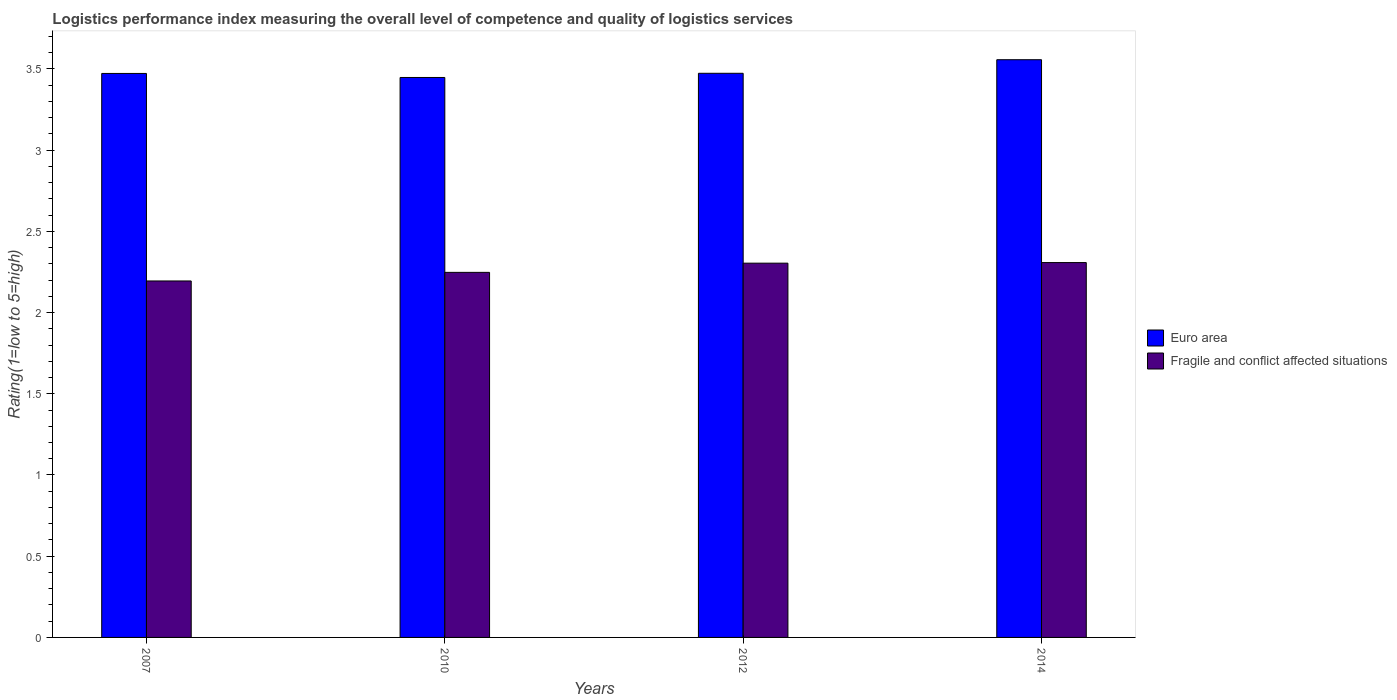How many different coloured bars are there?
Give a very brief answer. 2. How many bars are there on the 2nd tick from the left?
Your answer should be very brief. 2. What is the Logistic performance index in Euro area in 2012?
Ensure brevity in your answer.  3.47. Across all years, what is the maximum Logistic performance index in Fragile and conflict affected situations?
Provide a succinct answer. 2.31. Across all years, what is the minimum Logistic performance index in Fragile and conflict affected situations?
Give a very brief answer. 2.19. In which year was the Logistic performance index in Fragile and conflict affected situations minimum?
Your response must be concise. 2007. What is the total Logistic performance index in Euro area in the graph?
Provide a short and direct response. 13.95. What is the difference between the Logistic performance index in Fragile and conflict affected situations in 2007 and that in 2012?
Offer a terse response. -0.11. What is the difference between the Logistic performance index in Fragile and conflict affected situations in 2010 and the Logistic performance index in Euro area in 2014?
Your response must be concise. -1.31. What is the average Logistic performance index in Euro area per year?
Give a very brief answer. 3.49. In the year 2012, what is the difference between the Logistic performance index in Euro area and Logistic performance index in Fragile and conflict affected situations?
Make the answer very short. 1.17. What is the ratio of the Logistic performance index in Fragile and conflict affected situations in 2007 to that in 2014?
Make the answer very short. 0.95. Is the Logistic performance index in Fragile and conflict affected situations in 2007 less than that in 2014?
Keep it short and to the point. Yes. What is the difference between the highest and the second highest Logistic performance index in Euro area?
Provide a succinct answer. 0.08. What is the difference between the highest and the lowest Logistic performance index in Euro area?
Keep it short and to the point. 0.11. In how many years, is the Logistic performance index in Fragile and conflict affected situations greater than the average Logistic performance index in Fragile and conflict affected situations taken over all years?
Your answer should be very brief. 2. Is the sum of the Logistic performance index in Fragile and conflict affected situations in 2007 and 2010 greater than the maximum Logistic performance index in Euro area across all years?
Give a very brief answer. Yes. What does the 2nd bar from the right in 2012 represents?
Make the answer very short. Euro area. Are all the bars in the graph horizontal?
Provide a succinct answer. No. What is the difference between two consecutive major ticks on the Y-axis?
Your answer should be very brief. 0.5. Are the values on the major ticks of Y-axis written in scientific E-notation?
Ensure brevity in your answer.  No. Does the graph contain any zero values?
Your answer should be compact. No. Does the graph contain grids?
Your answer should be compact. No. Where does the legend appear in the graph?
Provide a short and direct response. Center right. How are the legend labels stacked?
Give a very brief answer. Vertical. What is the title of the graph?
Ensure brevity in your answer.  Logistics performance index measuring the overall level of competence and quality of logistics services. Does "Antigua and Barbuda" appear as one of the legend labels in the graph?
Ensure brevity in your answer.  No. What is the label or title of the Y-axis?
Your answer should be compact. Rating(1=low to 5=high). What is the Rating(1=low to 5=high) in Euro area in 2007?
Offer a very short reply. 3.47. What is the Rating(1=low to 5=high) in Fragile and conflict affected situations in 2007?
Your answer should be very brief. 2.19. What is the Rating(1=low to 5=high) of Euro area in 2010?
Your answer should be compact. 3.45. What is the Rating(1=low to 5=high) in Fragile and conflict affected situations in 2010?
Your response must be concise. 2.25. What is the Rating(1=low to 5=high) of Euro area in 2012?
Provide a short and direct response. 3.47. What is the Rating(1=low to 5=high) in Fragile and conflict affected situations in 2012?
Offer a very short reply. 2.3. What is the Rating(1=low to 5=high) in Euro area in 2014?
Provide a succinct answer. 3.56. What is the Rating(1=low to 5=high) in Fragile and conflict affected situations in 2014?
Give a very brief answer. 2.31. Across all years, what is the maximum Rating(1=low to 5=high) of Euro area?
Ensure brevity in your answer.  3.56. Across all years, what is the maximum Rating(1=low to 5=high) of Fragile and conflict affected situations?
Offer a terse response. 2.31. Across all years, what is the minimum Rating(1=low to 5=high) of Euro area?
Ensure brevity in your answer.  3.45. Across all years, what is the minimum Rating(1=low to 5=high) in Fragile and conflict affected situations?
Your answer should be very brief. 2.19. What is the total Rating(1=low to 5=high) in Euro area in the graph?
Provide a succinct answer. 13.95. What is the total Rating(1=low to 5=high) of Fragile and conflict affected situations in the graph?
Offer a very short reply. 9.05. What is the difference between the Rating(1=low to 5=high) of Euro area in 2007 and that in 2010?
Your response must be concise. 0.02. What is the difference between the Rating(1=low to 5=high) in Fragile and conflict affected situations in 2007 and that in 2010?
Keep it short and to the point. -0.05. What is the difference between the Rating(1=low to 5=high) of Euro area in 2007 and that in 2012?
Keep it short and to the point. -0. What is the difference between the Rating(1=low to 5=high) in Fragile and conflict affected situations in 2007 and that in 2012?
Provide a short and direct response. -0.11. What is the difference between the Rating(1=low to 5=high) of Euro area in 2007 and that in 2014?
Your response must be concise. -0.08. What is the difference between the Rating(1=low to 5=high) of Fragile and conflict affected situations in 2007 and that in 2014?
Offer a terse response. -0.11. What is the difference between the Rating(1=low to 5=high) in Euro area in 2010 and that in 2012?
Your answer should be compact. -0.03. What is the difference between the Rating(1=low to 5=high) of Fragile and conflict affected situations in 2010 and that in 2012?
Provide a short and direct response. -0.06. What is the difference between the Rating(1=low to 5=high) in Euro area in 2010 and that in 2014?
Keep it short and to the point. -0.11. What is the difference between the Rating(1=low to 5=high) in Fragile and conflict affected situations in 2010 and that in 2014?
Your response must be concise. -0.06. What is the difference between the Rating(1=low to 5=high) of Euro area in 2012 and that in 2014?
Offer a very short reply. -0.08. What is the difference between the Rating(1=low to 5=high) of Fragile and conflict affected situations in 2012 and that in 2014?
Keep it short and to the point. -0. What is the difference between the Rating(1=low to 5=high) of Euro area in 2007 and the Rating(1=low to 5=high) of Fragile and conflict affected situations in 2010?
Give a very brief answer. 1.22. What is the difference between the Rating(1=low to 5=high) in Euro area in 2007 and the Rating(1=low to 5=high) in Fragile and conflict affected situations in 2012?
Your answer should be compact. 1.17. What is the difference between the Rating(1=low to 5=high) in Euro area in 2007 and the Rating(1=low to 5=high) in Fragile and conflict affected situations in 2014?
Provide a short and direct response. 1.16. What is the difference between the Rating(1=low to 5=high) in Euro area in 2010 and the Rating(1=low to 5=high) in Fragile and conflict affected situations in 2012?
Your answer should be compact. 1.14. What is the difference between the Rating(1=low to 5=high) in Euro area in 2010 and the Rating(1=low to 5=high) in Fragile and conflict affected situations in 2014?
Keep it short and to the point. 1.14. What is the difference between the Rating(1=low to 5=high) of Euro area in 2012 and the Rating(1=low to 5=high) of Fragile and conflict affected situations in 2014?
Make the answer very short. 1.17. What is the average Rating(1=low to 5=high) of Euro area per year?
Your answer should be very brief. 3.49. What is the average Rating(1=low to 5=high) of Fragile and conflict affected situations per year?
Make the answer very short. 2.26. In the year 2007, what is the difference between the Rating(1=low to 5=high) of Euro area and Rating(1=low to 5=high) of Fragile and conflict affected situations?
Offer a terse response. 1.28. In the year 2010, what is the difference between the Rating(1=low to 5=high) of Euro area and Rating(1=low to 5=high) of Fragile and conflict affected situations?
Your answer should be compact. 1.2. In the year 2012, what is the difference between the Rating(1=low to 5=high) in Euro area and Rating(1=low to 5=high) in Fragile and conflict affected situations?
Your answer should be very brief. 1.17. In the year 2014, what is the difference between the Rating(1=low to 5=high) in Euro area and Rating(1=low to 5=high) in Fragile and conflict affected situations?
Make the answer very short. 1.25. What is the ratio of the Rating(1=low to 5=high) in Euro area in 2007 to that in 2010?
Your response must be concise. 1.01. What is the ratio of the Rating(1=low to 5=high) of Fragile and conflict affected situations in 2007 to that in 2010?
Your response must be concise. 0.98. What is the ratio of the Rating(1=low to 5=high) in Euro area in 2007 to that in 2012?
Give a very brief answer. 1. What is the ratio of the Rating(1=low to 5=high) in Fragile and conflict affected situations in 2007 to that in 2012?
Your answer should be very brief. 0.95. What is the ratio of the Rating(1=low to 5=high) of Euro area in 2007 to that in 2014?
Provide a short and direct response. 0.98. What is the ratio of the Rating(1=low to 5=high) in Fragile and conflict affected situations in 2007 to that in 2014?
Provide a succinct answer. 0.95. What is the ratio of the Rating(1=low to 5=high) of Fragile and conflict affected situations in 2010 to that in 2012?
Give a very brief answer. 0.98. What is the ratio of the Rating(1=low to 5=high) in Euro area in 2010 to that in 2014?
Your answer should be very brief. 0.97. What is the ratio of the Rating(1=low to 5=high) of Fragile and conflict affected situations in 2010 to that in 2014?
Ensure brevity in your answer.  0.97. What is the ratio of the Rating(1=low to 5=high) in Euro area in 2012 to that in 2014?
Your answer should be compact. 0.98. What is the difference between the highest and the second highest Rating(1=low to 5=high) in Euro area?
Your answer should be very brief. 0.08. What is the difference between the highest and the second highest Rating(1=low to 5=high) in Fragile and conflict affected situations?
Ensure brevity in your answer.  0. What is the difference between the highest and the lowest Rating(1=low to 5=high) of Euro area?
Ensure brevity in your answer.  0.11. What is the difference between the highest and the lowest Rating(1=low to 5=high) of Fragile and conflict affected situations?
Offer a very short reply. 0.11. 